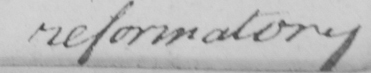Please provide the text content of this handwritten line. reformatory 